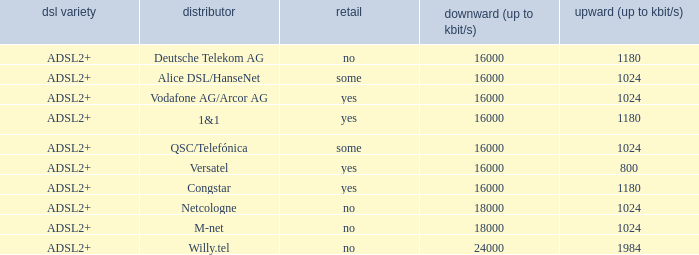Parse the table in full. {'header': ['dsl variety', 'distributor', 'retail', 'downward (up to kbit/s)', 'upward (up to kbit/s)'], 'rows': [['ADSL2+', 'Deutsche Telekom AG', 'no', '16000', '1180'], ['ADSL2+', 'Alice DSL/HanseNet', 'some', '16000', '1024'], ['ADSL2+', 'Vodafone AG/Arcor AG', 'yes', '16000', '1024'], ['ADSL2+', '1&1', 'yes', '16000', '1180'], ['ADSL2+', 'QSC/Telefónica', 'some', '16000', '1024'], ['ADSL2+', 'Versatel', 'yes', '16000', '800'], ['ADSL2+', 'Congstar', 'yes', '16000', '1180'], ['ADSL2+', 'Netcologne', 'no', '18000', '1024'], ['ADSL2+', 'M-net', 'no', '18000', '1024'], ['ADSL2+', 'Willy.tel', 'no', '24000', '1984']]} Who are all of the telecom providers for which the upload rate is 1024 kbits and the resale category is yes? Vodafone AG/Arcor AG. 